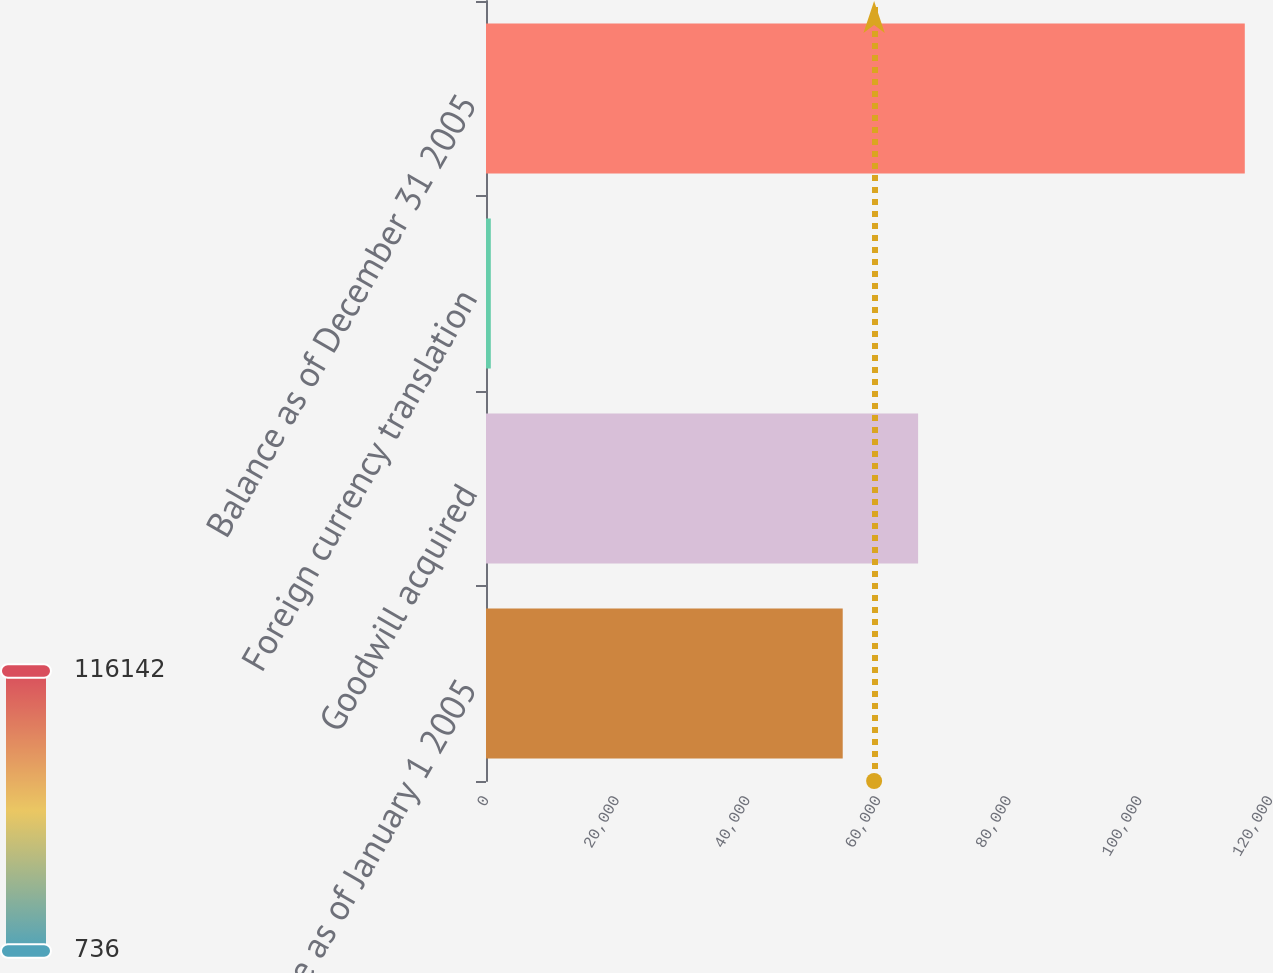Convert chart. <chart><loc_0><loc_0><loc_500><loc_500><bar_chart><fcel>Balance as of January 1 2005<fcel>Goodwill acquired<fcel>Foreign currency translation<fcel>Balance as of December 31 2005<nl><fcel>54600<fcel>66140.6<fcel>736<fcel>116142<nl></chart> 